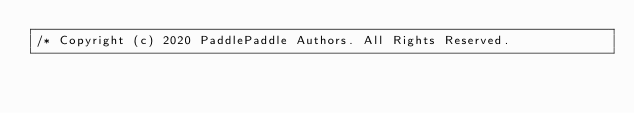Convert code to text. <code><loc_0><loc_0><loc_500><loc_500><_C++_>/* Copyright (c) 2020 PaddlePaddle Authors. All Rights Reserved.
</code> 